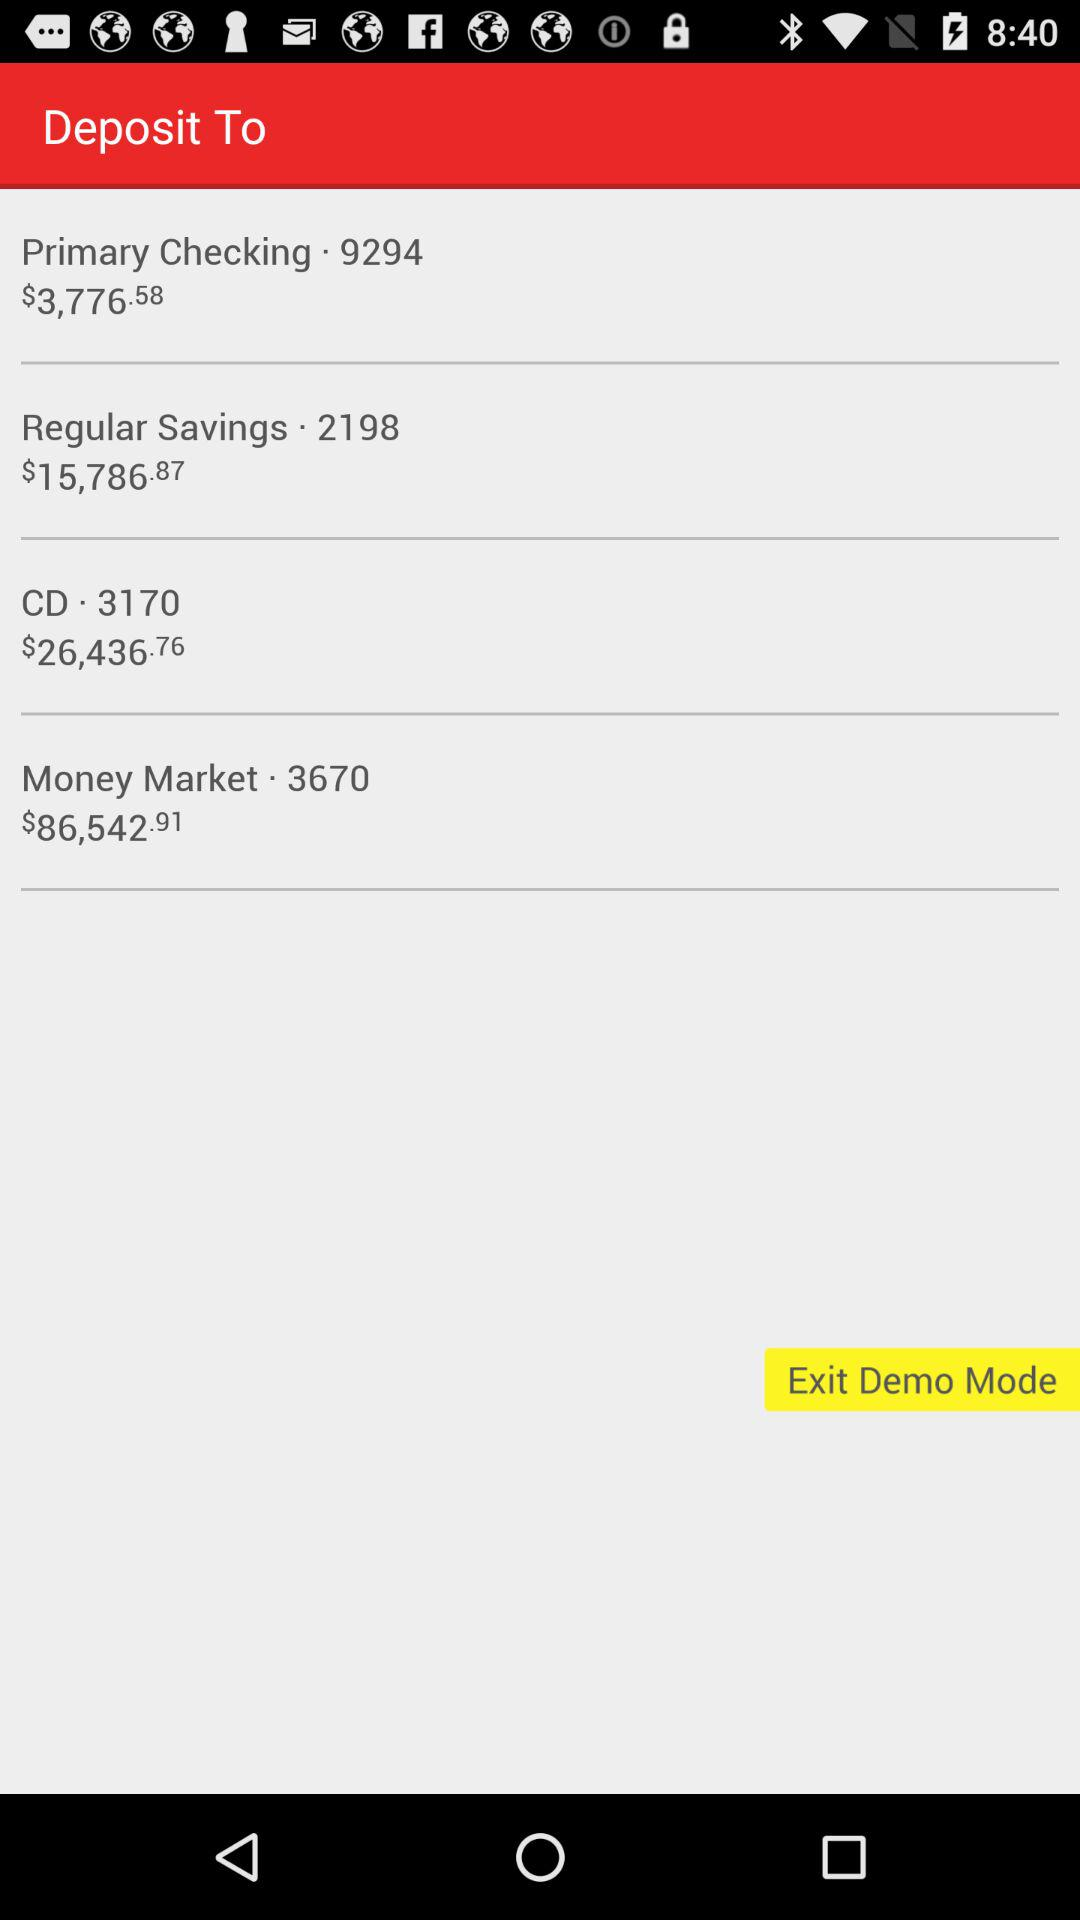How much balance is there in the money market account? The balance in the money market account is $86,542.91. 